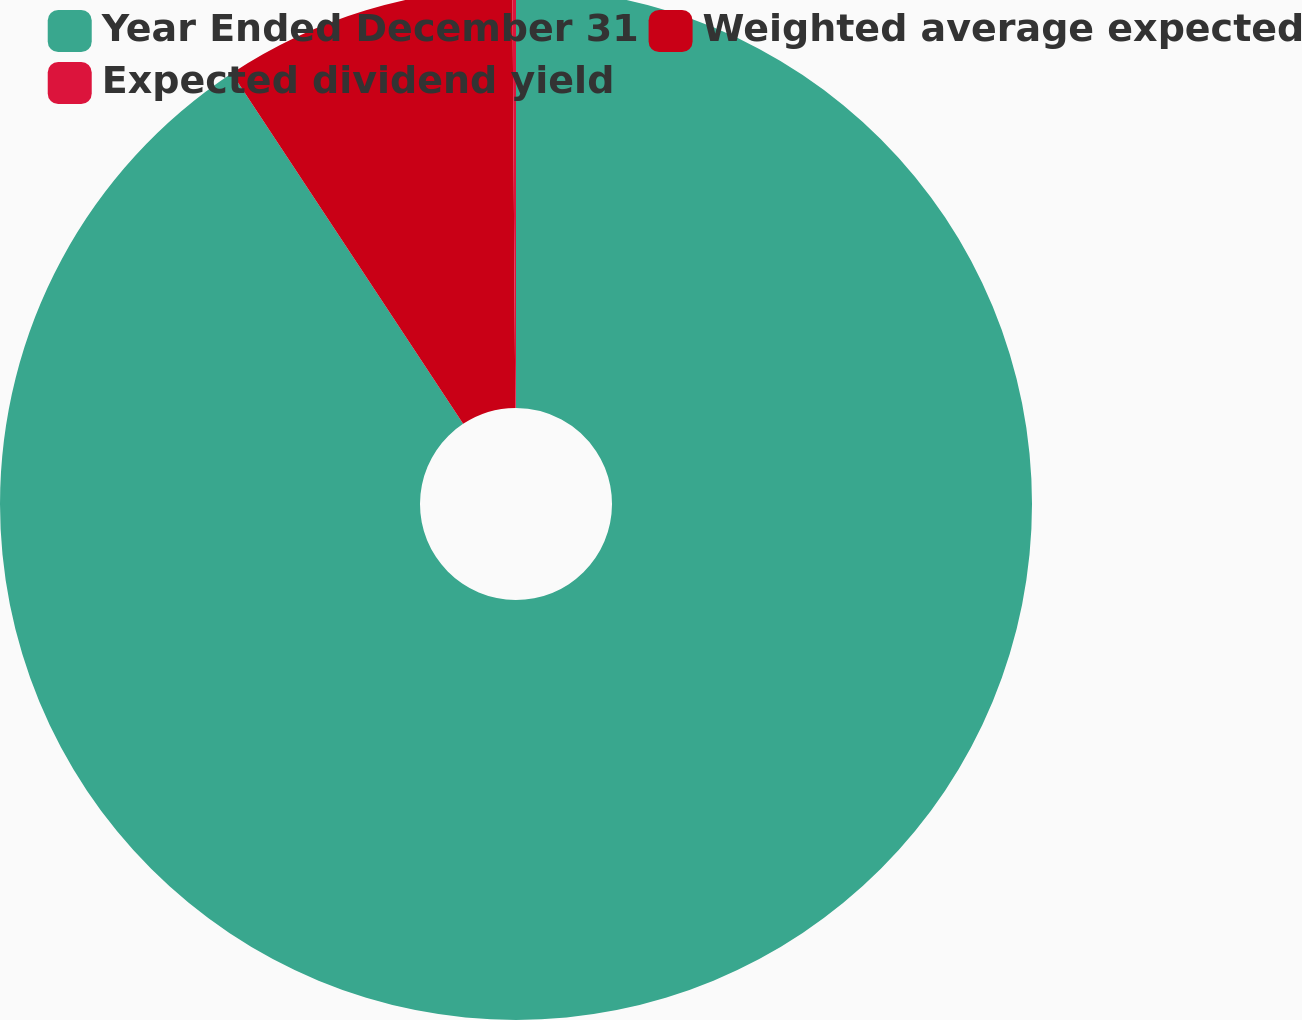<chart> <loc_0><loc_0><loc_500><loc_500><pie_chart><fcel>Year Ended December 31<fcel>Weighted average expected<fcel>Expected dividend yield<nl><fcel>90.71%<fcel>9.17%<fcel>0.11%<nl></chart> 